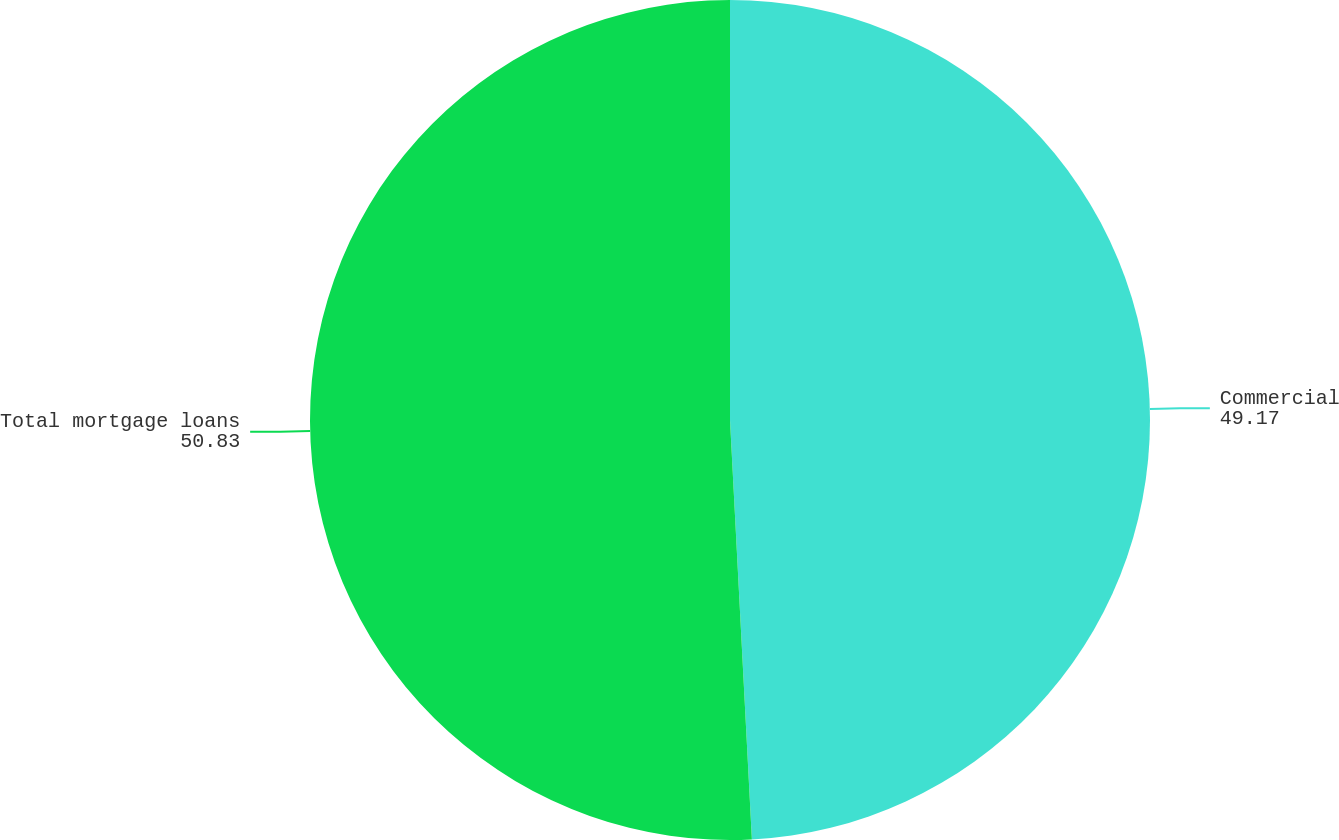Convert chart to OTSL. <chart><loc_0><loc_0><loc_500><loc_500><pie_chart><fcel>Commercial<fcel>Total mortgage loans<nl><fcel>49.17%<fcel>50.83%<nl></chart> 